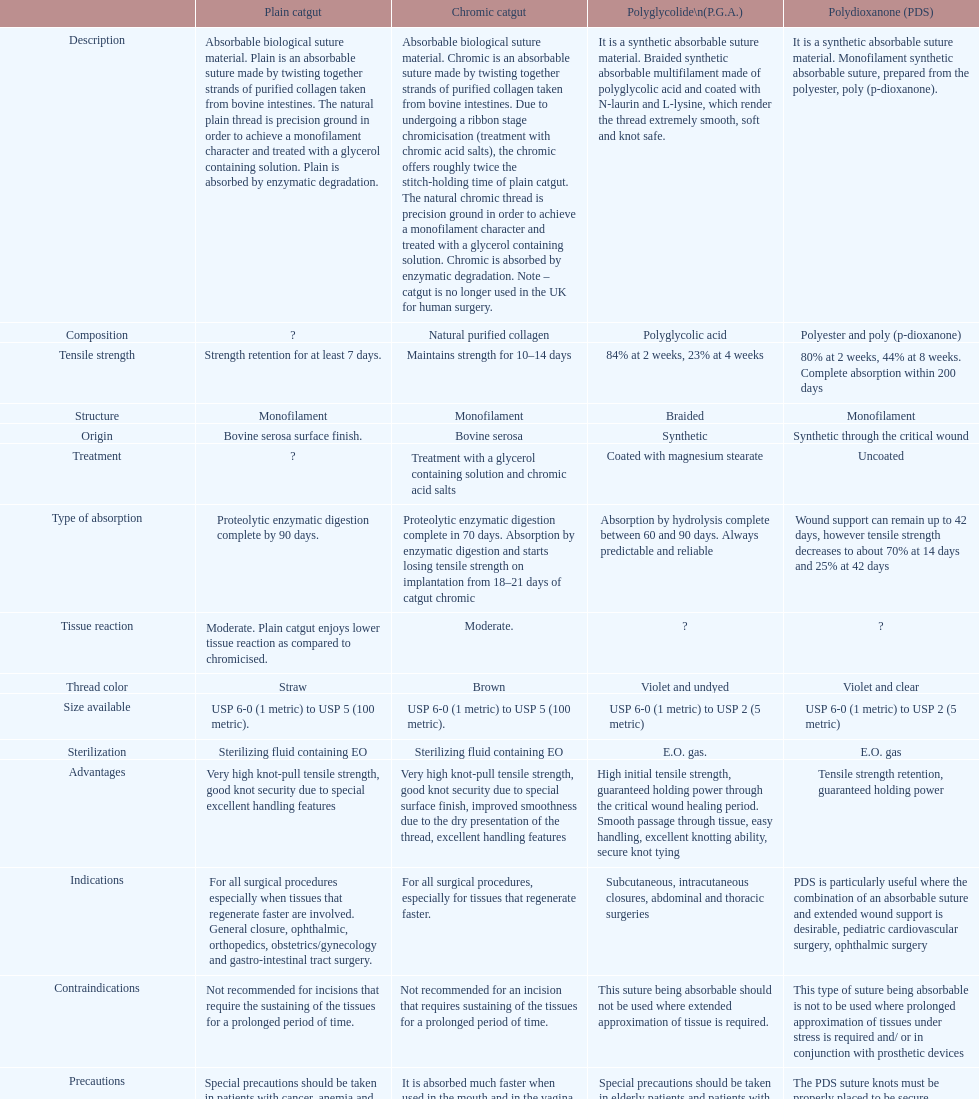The basic catgut sustains its sturdiness for no less than how many days? Strength retention for at least 7 days. 